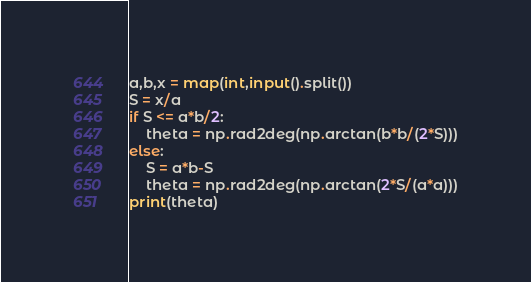<code> <loc_0><loc_0><loc_500><loc_500><_Python_>a,b,x = map(int,input().split())
S = x/a
if S <= a*b/2:
    theta = np.rad2deg(np.arctan(b*b/(2*S)))
else:
    S = a*b-S
    theta = np.rad2deg(np.arctan(2*S/(a*a)))
print(theta)</code> 